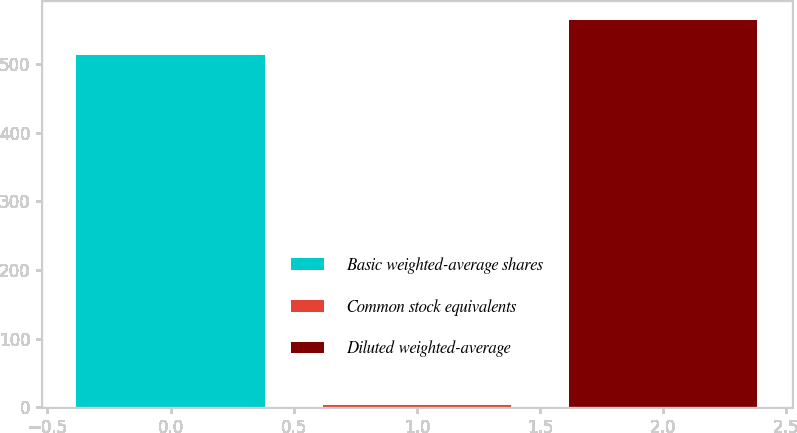Convert chart to OTSL. <chart><loc_0><loc_0><loc_500><loc_500><bar_chart><fcel>Basic weighted-average shares<fcel>Common stock equivalents<fcel>Diluted weighted-average<nl><fcel>512.6<fcel>4.1<fcel>563.86<nl></chart> 